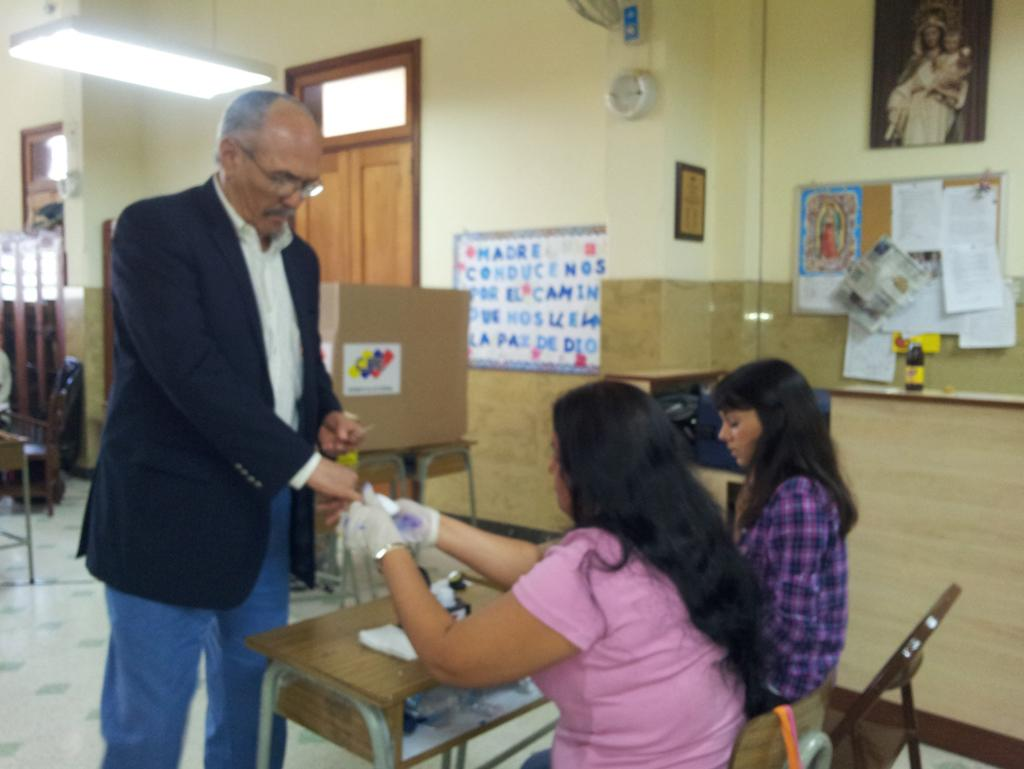What is the primary action being performed by the person in the image? There is a person standing in the image. How many people are sitting in the image? There are two people sitting on benches in the image. What type of paste is being sold in the shop in the image? There is no shop or paste present in the image; it features a person standing and two people sitting on benches. How many apples are visible on the person standing in the image? There are no apples visible on the person standing in the image. 